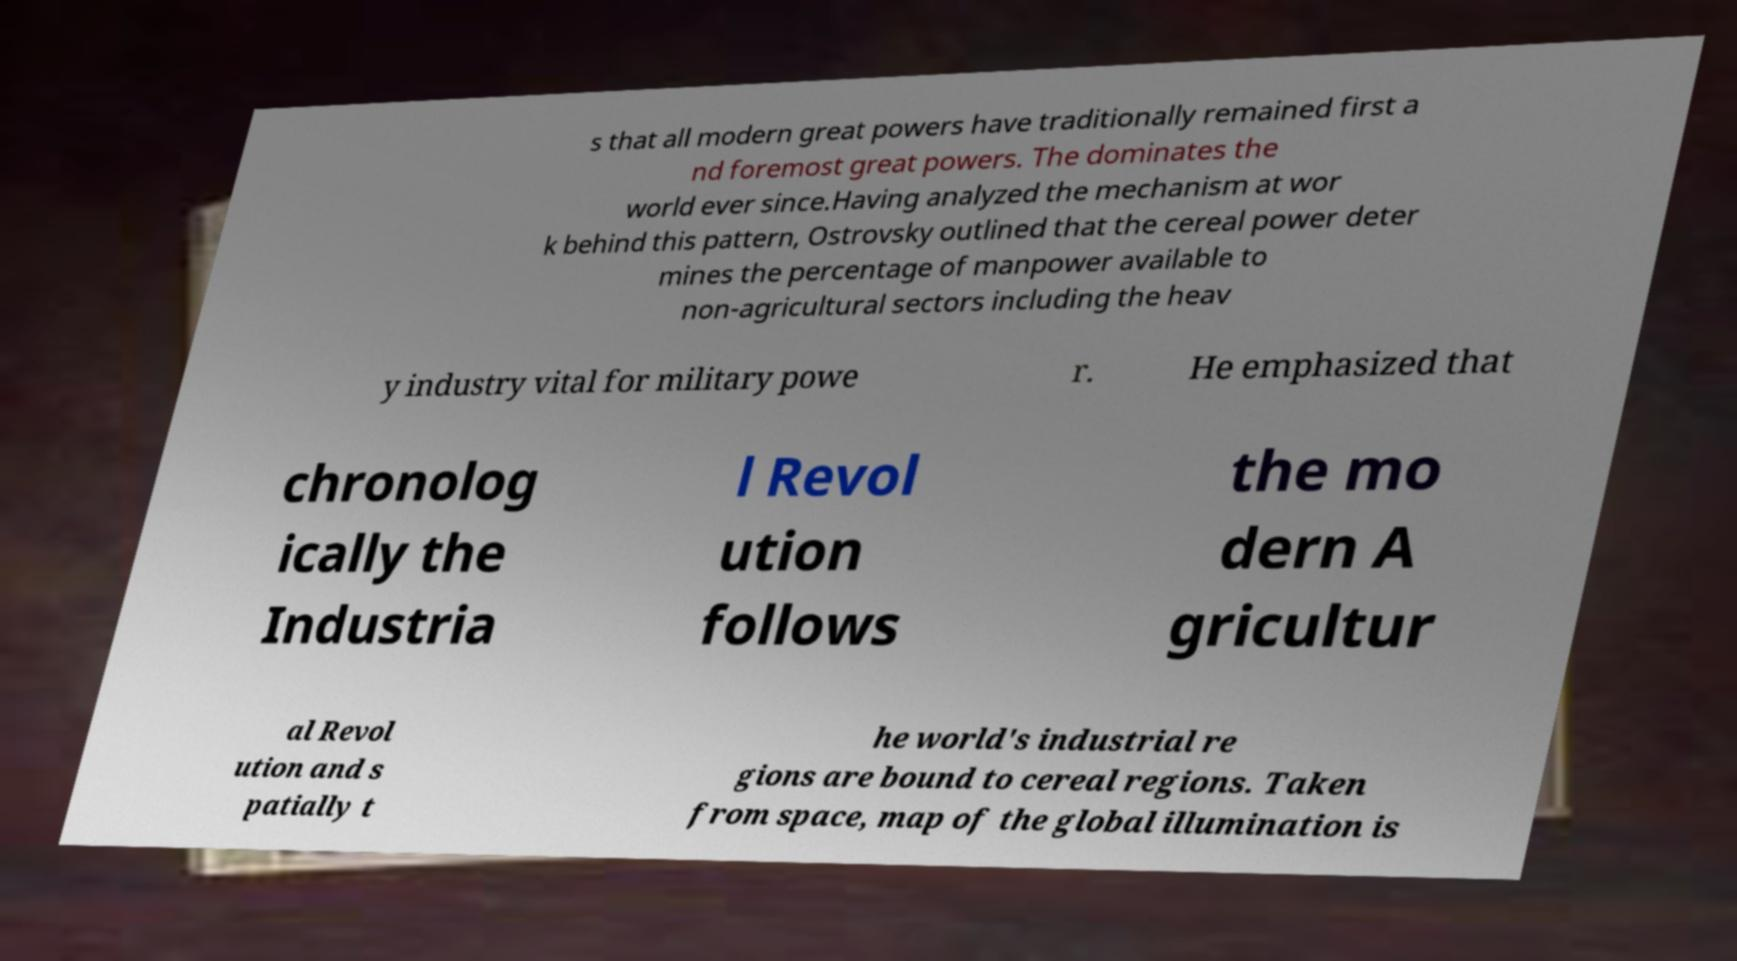Can you read and provide the text displayed in the image?This photo seems to have some interesting text. Can you extract and type it out for me? s that all modern great powers have traditionally remained first a nd foremost great powers. The dominates the world ever since.Having analyzed the mechanism at wor k behind this pattern, Ostrovsky outlined that the cereal power deter mines the percentage of manpower available to non-agricultural sectors including the heav y industry vital for military powe r. He emphasized that chronolog ically the Industria l Revol ution follows the mo dern A gricultur al Revol ution and s patially t he world's industrial re gions are bound to cereal regions. Taken from space, map of the global illumination is 